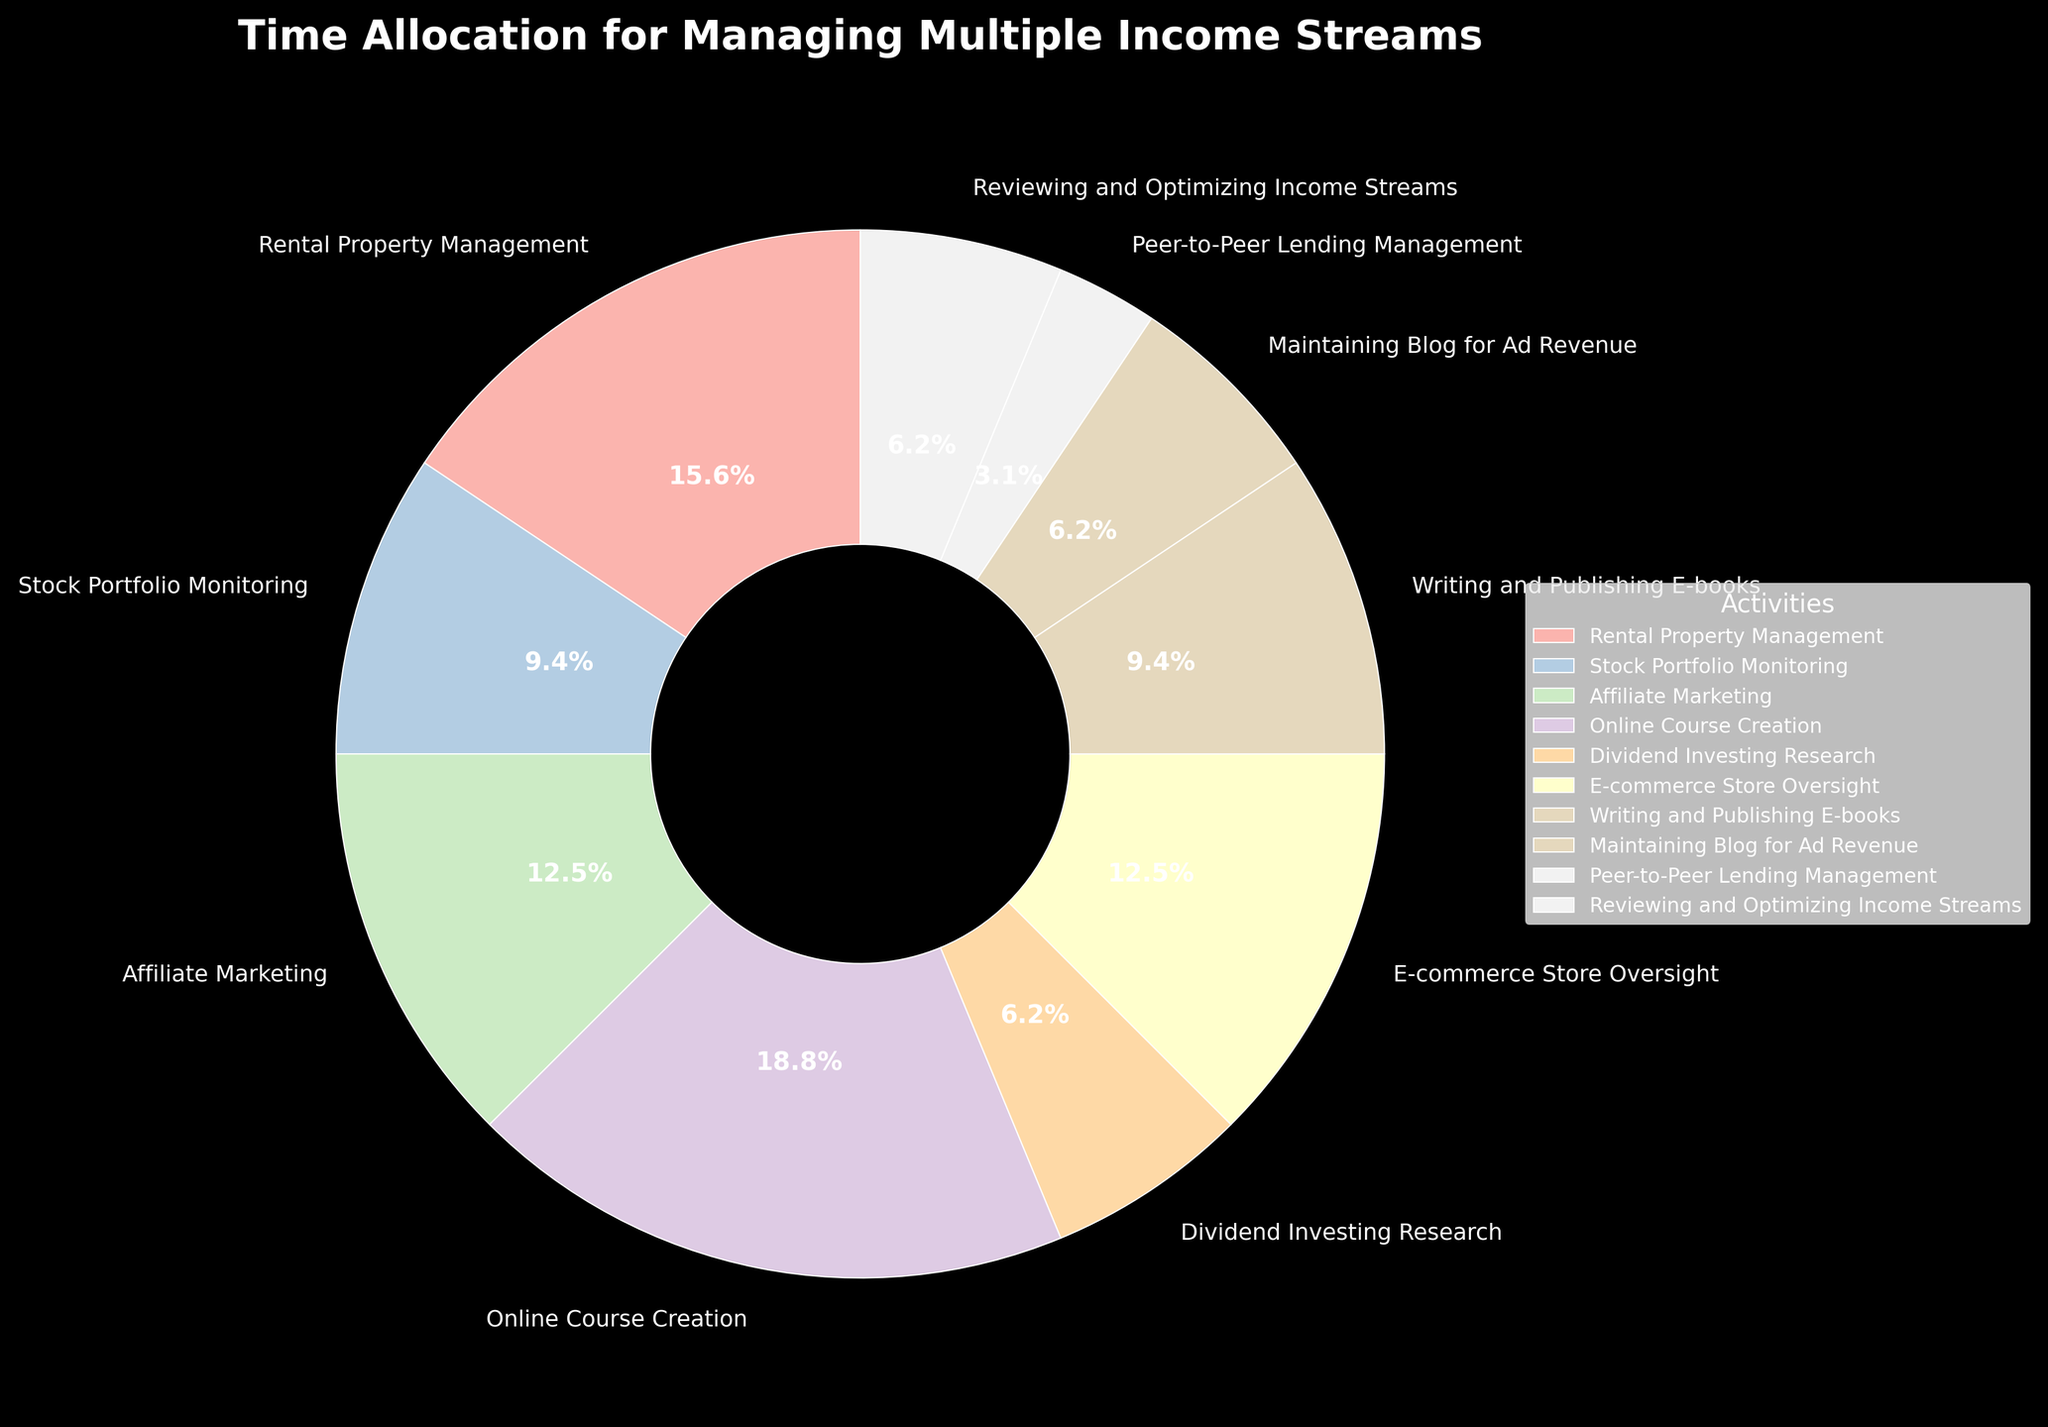Which activity takes up the largest percentage of time? By observing the size of the wedges in the pie chart, the largest wedge corresponds to the "Online Course Creation" activity.
Answer: Online Course Creation Which two activities combined take up the same amount of time as Online Course Creation? First, note that Online Course Creation occupies 6 hours per week. Then identify two activities whose combined hours equal 6. Rental Property Management (5 hours) + Peer-to-Peer Lending Management (1 hour) equals 6 hours.
Answer: Rental Property Management and Peer-to-Peer Lending Management How much more time is spent on E-commerce Store Oversight compared to Affiliate Marketing? Affiliate Marketing is 4 hours and E-commerce Store Oversight is also 4 hours. Both activities take the same amount of time.
Answer: 0 hours What is the total time spent on maintaining the blog and reviewing income streams? Maintaining Blog for Ad Revenue is 2 hours and Reviewing and Optimizing Income Streams is also 2 hours. Adding these gives 2 + 2 = 4 hours.
Answer: 4 hours If you were to reduce time spent on Affiliate Marketing and allocate it to Dividend Investing Research, what would the new percentage for Dividend Investing Research be? Affiliate Marketing takes 4 hours, reallocating this to Dividend Investing Research would add to its original 2 hours, making it 6 hours. The total hours per week is 32. The new percentage is (6/32)*100 = 18.75%.
Answer: 18.75% How much more time is spent on Online Course Creation than on Stock Portfolio Monitoring? Online Course Creation is 6 hours, and Stock Portfolio Monitoring is 3 hours. The difference between the two is 6 - 3 = 3 hours.
Answer: 3 hours What percentage of the week is spent on activities that require exactly 2 hours each? There are three activities requiring exactly 2 hours each: Dividend Investing Research, Maintaining Blog for Ad Revenue, and Reviewing and Optimizing Income Streams. The total hours is 2 + 2 + 2 = 6. The percentage is (6/32)*100 = 18.75%.
Answer: 18.75% Which activity is allocated the least amount of time, and what percentage does it represent? Peer-to-Peer Lending Management is allocated the least time, 1 hour. The percentage is (1/32)*100 = 3.125%.
Answer: Peer-to-Peer Lending Management, 3.125% What is the proportion of time spent on Online Course Creation relative to the total time for all income streams? Online Course Creation is 6 hours. The total time is 32 hours. Hence, the proportion is 6/32.
Answer: 6/32 If time spent writing and publishing e-books was doubled, how many hours would that be, and what percentage of the total would it represent? Writing and Publishing E-books is currently 3 hours. Doubling this would be 6 hours. The total time becomes 35 hours. The percentage is (6/35)*100 ≈ 17.14%.
Answer: 6 hours, 17.14% 